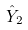Convert formula to latex. <formula><loc_0><loc_0><loc_500><loc_500>\hat { Y } _ { 2 }</formula> 